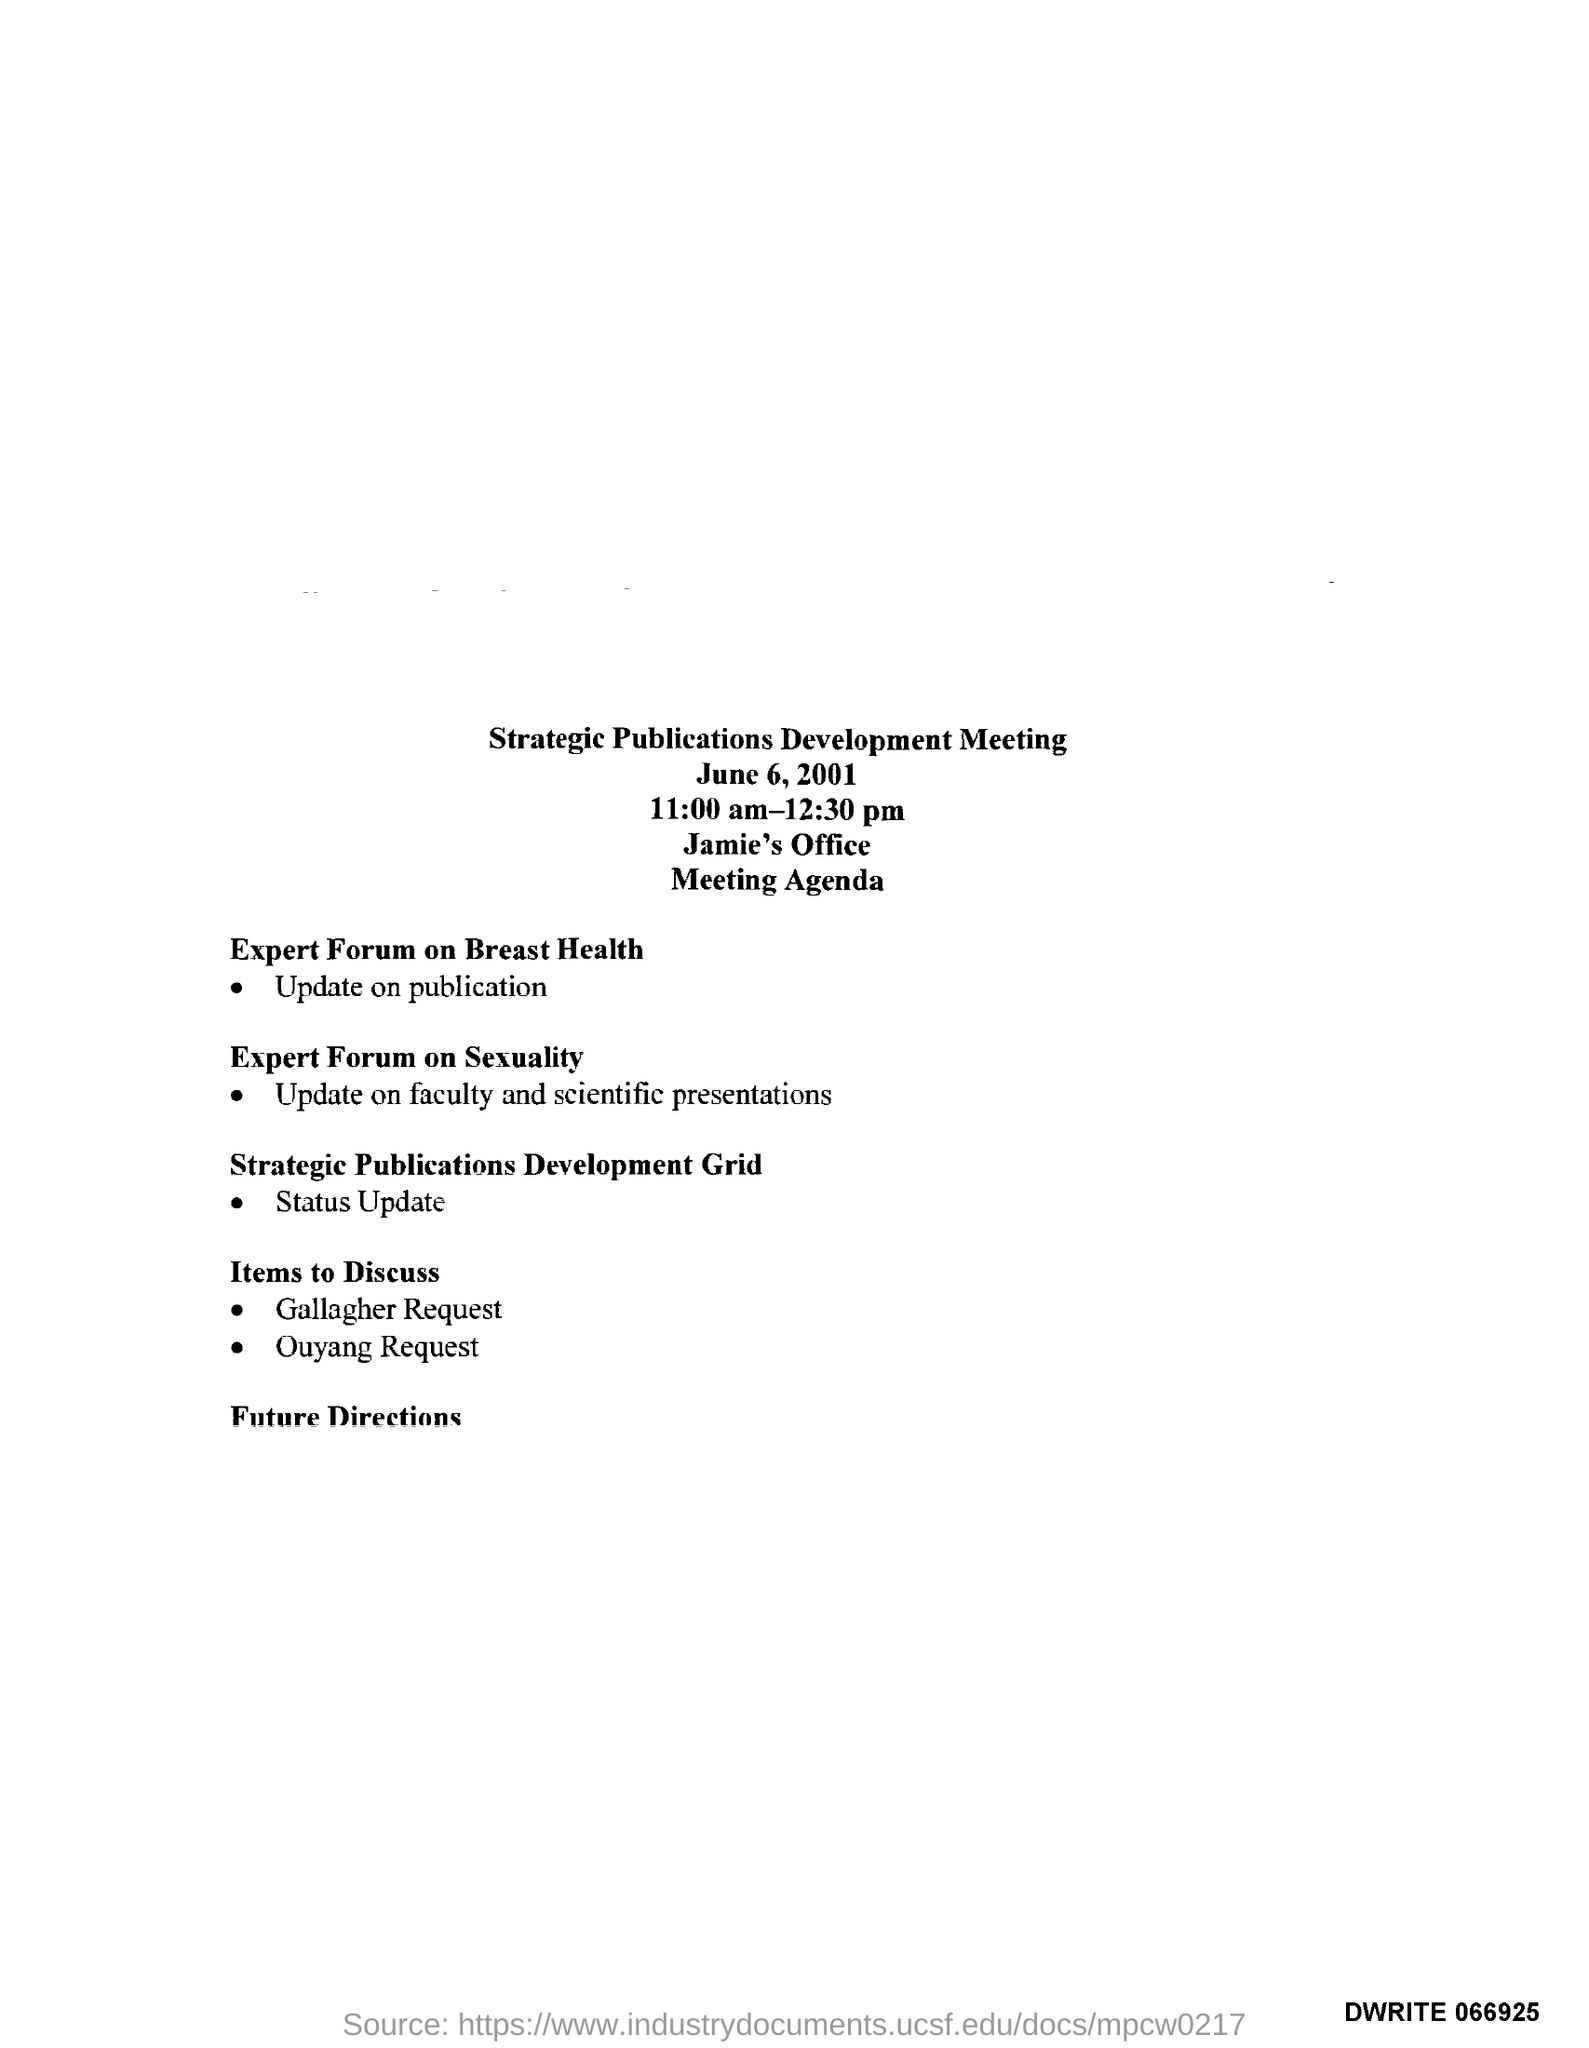Highlight a few significant elements in this photo. The meeting was held in Jamie's office. The meeting took place from 11:00 am to 12:30 pm. The title of this meeting is a Strategic Publication Development Meeting. The meeting was held on June 6, 2001. The first main agenda of the EXPERT FORUM ON BREAST HEALTH is? 